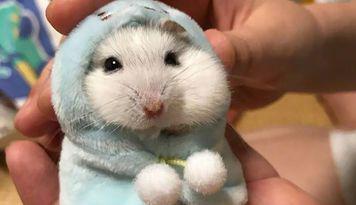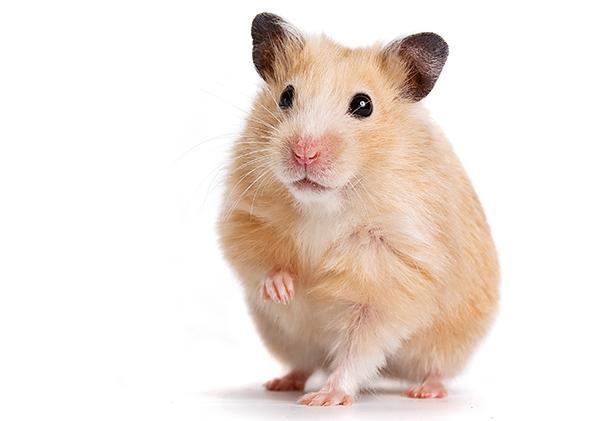The first image is the image on the left, the second image is the image on the right. Examine the images to the left and right. Is the description "One of the images has a plain white background." accurate? Answer yes or no. Yes. 